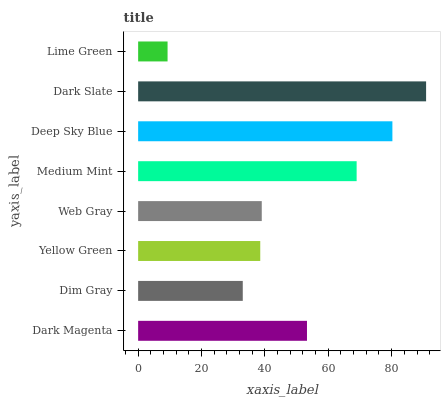Is Lime Green the minimum?
Answer yes or no. Yes. Is Dark Slate the maximum?
Answer yes or no. Yes. Is Dim Gray the minimum?
Answer yes or no. No. Is Dim Gray the maximum?
Answer yes or no. No. Is Dark Magenta greater than Dim Gray?
Answer yes or no. Yes. Is Dim Gray less than Dark Magenta?
Answer yes or no. Yes. Is Dim Gray greater than Dark Magenta?
Answer yes or no. No. Is Dark Magenta less than Dim Gray?
Answer yes or no. No. Is Dark Magenta the high median?
Answer yes or no. Yes. Is Web Gray the low median?
Answer yes or no. Yes. Is Medium Mint the high median?
Answer yes or no. No. Is Deep Sky Blue the low median?
Answer yes or no. No. 